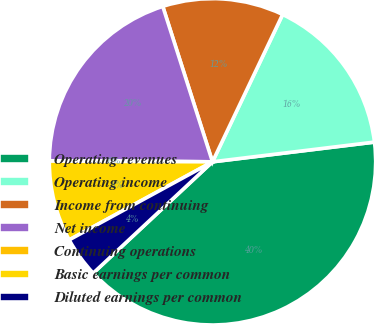Convert chart. <chart><loc_0><loc_0><loc_500><loc_500><pie_chart><fcel>Operating revenues<fcel>Operating income<fcel>Income from continuing<fcel>Net income<fcel>Continuing operations<fcel>Basic earnings per common<fcel>Diluted earnings per common<nl><fcel>39.98%<fcel>16.0%<fcel>12.0%<fcel>19.99%<fcel>0.01%<fcel>8.01%<fcel>4.01%<nl></chart> 